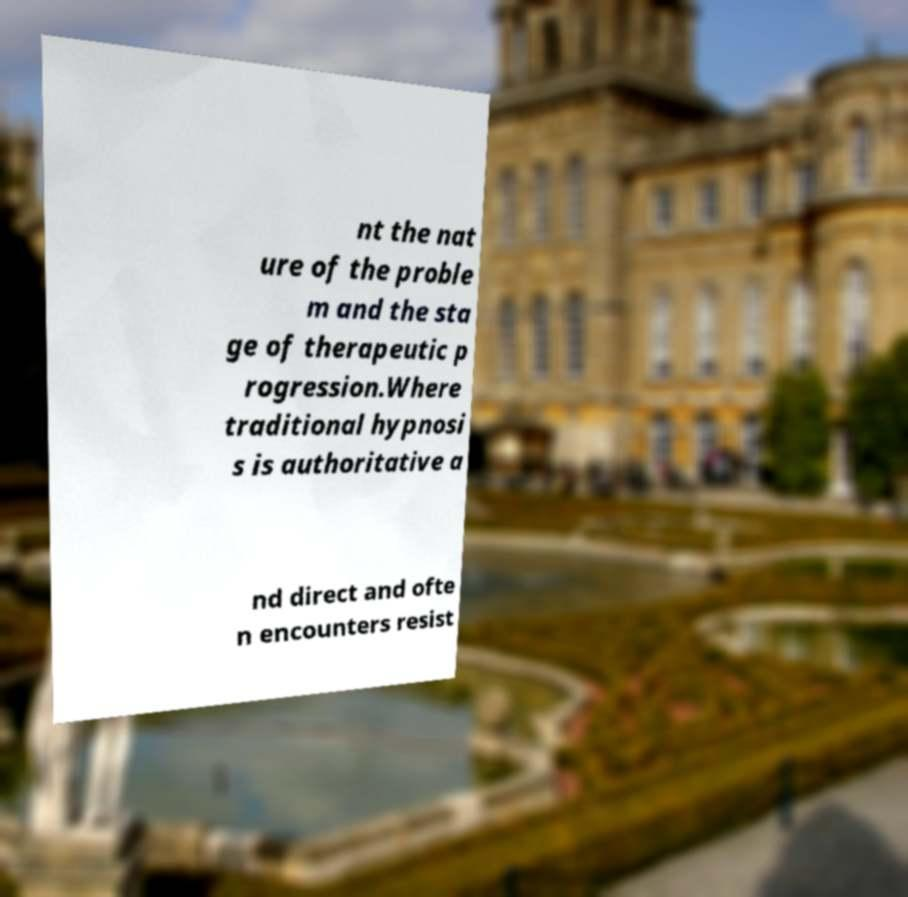Please identify and transcribe the text found in this image. nt the nat ure of the proble m and the sta ge of therapeutic p rogression.Where traditional hypnosi s is authoritative a nd direct and ofte n encounters resist 